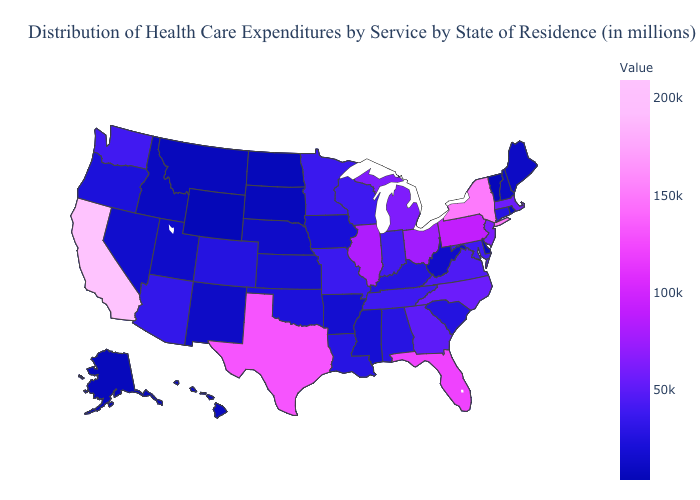Which states have the highest value in the USA?
Be succinct. California. Does the map have missing data?
Short answer required. No. Among the states that border Nebraska , does Iowa have the highest value?
Quick response, please. No. Does New York have the highest value in the Northeast?
Concise answer only. Yes. Which states have the lowest value in the South?
Answer briefly. Delaware. Does the map have missing data?
Write a very short answer. No. Does the map have missing data?
Keep it brief. No. 